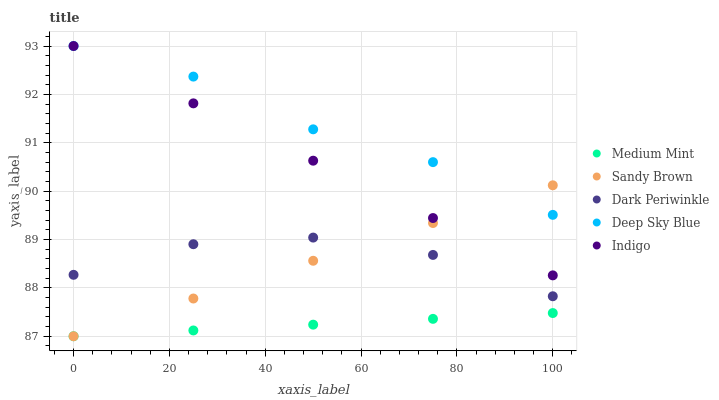Does Medium Mint have the minimum area under the curve?
Answer yes or no. Yes. Does Deep Sky Blue have the maximum area under the curve?
Answer yes or no. Yes. Does Indigo have the minimum area under the curve?
Answer yes or no. No. Does Indigo have the maximum area under the curve?
Answer yes or no. No. Is Medium Mint the smoothest?
Answer yes or no. Yes. Is Dark Periwinkle the roughest?
Answer yes or no. Yes. Is Indigo the smoothest?
Answer yes or no. No. Is Indigo the roughest?
Answer yes or no. No. Does Medium Mint have the lowest value?
Answer yes or no. Yes. Does Indigo have the lowest value?
Answer yes or no. No. Does Deep Sky Blue have the highest value?
Answer yes or no. Yes. Does Sandy Brown have the highest value?
Answer yes or no. No. Is Dark Periwinkle less than Deep Sky Blue?
Answer yes or no. Yes. Is Dark Periwinkle greater than Medium Mint?
Answer yes or no. Yes. Does Deep Sky Blue intersect Sandy Brown?
Answer yes or no. Yes. Is Deep Sky Blue less than Sandy Brown?
Answer yes or no. No. Is Deep Sky Blue greater than Sandy Brown?
Answer yes or no. No. Does Dark Periwinkle intersect Deep Sky Blue?
Answer yes or no. No. 